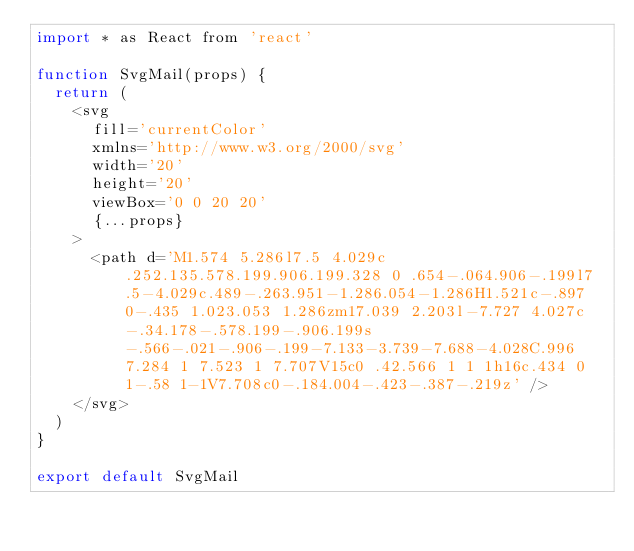Convert code to text. <code><loc_0><loc_0><loc_500><loc_500><_JavaScript_>import * as React from 'react'

function SvgMail(props) {
  return (
    <svg
      fill='currentColor'
      xmlns='http://www.w3.org/2000/svg'
      width='20'
      height='20'
      viewBox='0 0 20 20'
      {...props}
    >
      <path d='M1.574 5.286l7.5 4.029c.252.135.578.199.906.199.328 0 .654-.064.906-.199l7.5-4.029c.489-.263.951-1.286.054-1.286H1.521c-.897 0-.435 1.023.053 1.286zm17.039 2.203l-7.727 4.027c-.34.178-.578.199-.906.199s-.566-.021-.906-.199-7.133-3.739-7.688-4.028C.996 7.284 1 7.523 1 7.707V15c0 .42.566 1 1 1h16c.434 0 1-.58 1-1V7.708c0-.184.004-.423-.387-.219z' />
    </svg>
  )
}

export default SvgMail
</code> 